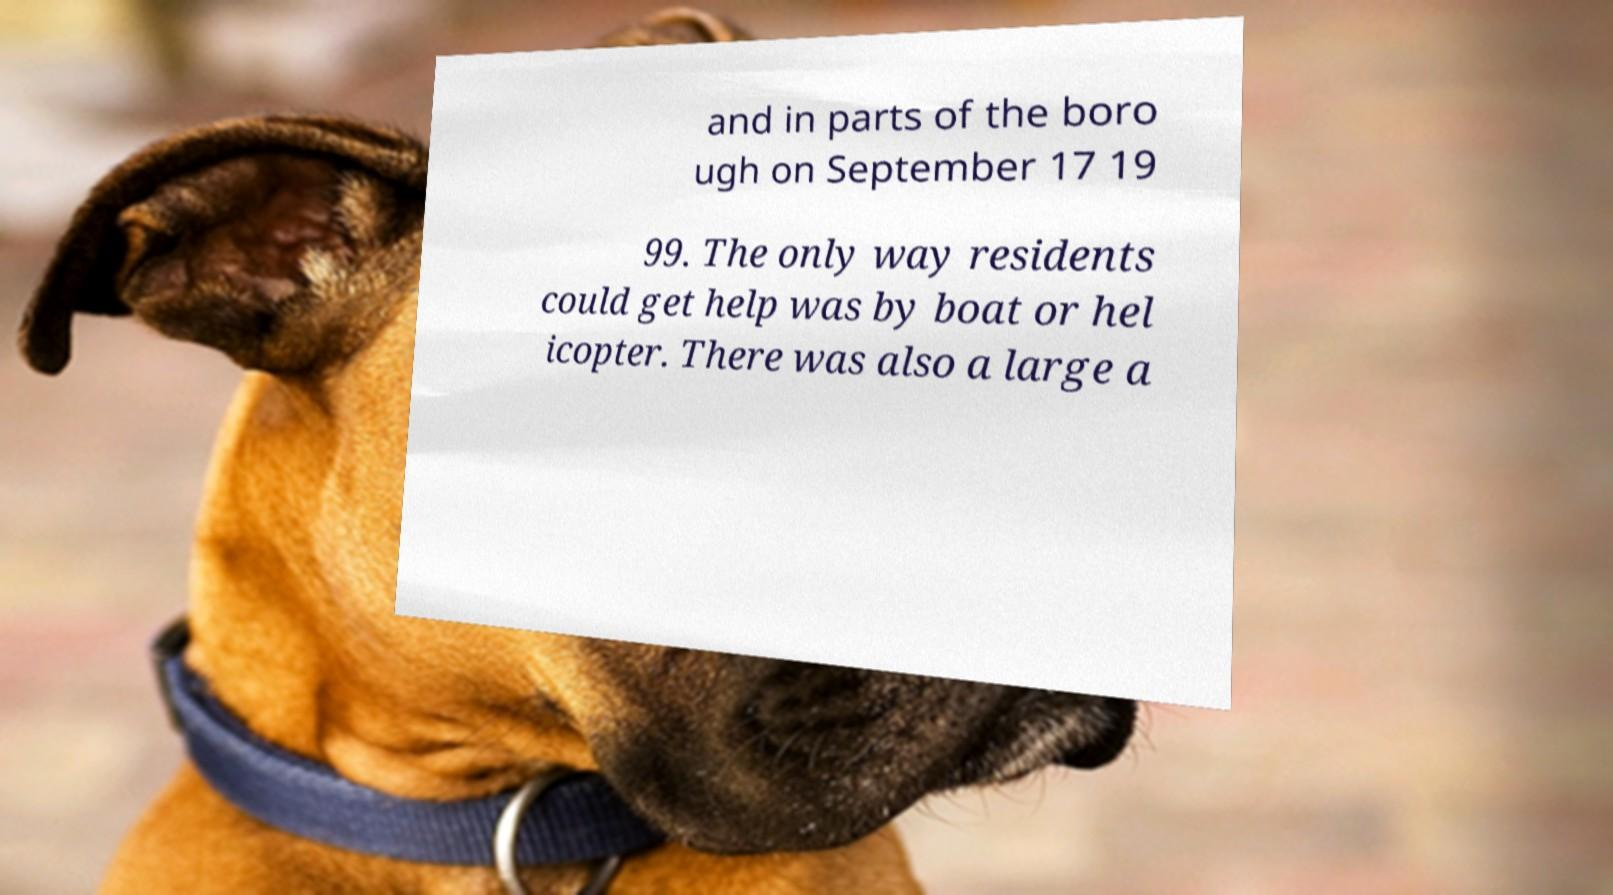Please identify and transcribe the text found in this image. and in parts of the boro ugh on September 17 19 99. The only way residents could get help was by boat or hel icopter. There was also a large a 